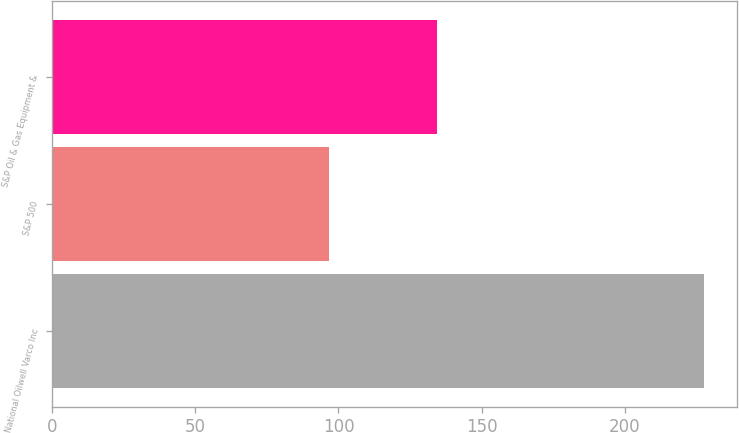<chart> <loc_0><loc_0><loc_500><loc_500><bar_chart><fcel>National Oilwell Varco Inc<fcel>S&P 500<fcel>S&P Oil & Gas Equipment &<nl><fcel>227.59<fcel>96.71<fcel>134.38<nl></chart> 